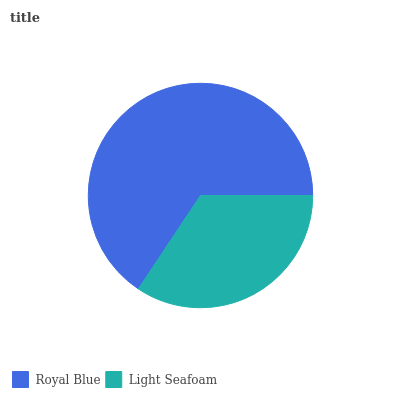Is Light Seafoam the minimum?
Answer yes or no. Yes. Is Royal Blue the maximum?
Answer yes or no. Yes. Is Light Seafoam the maximum?
Answer yes or no. No. Is Royal Blue greater than Light Seafoam?
Answer yes or no. Yes. Is Light Seafoam less than Royal Blue?
Answer yes or no. Yes. Is Light Seafoam greater than Royal Blue?
Answer yes or no. No. Is Royal Blue less than Light Seafoam?
Answer yes or no. No. Is Royal Blue the high median?
Answer yes or no. Yes. Is Light Seafoam the low median?
Answer yes or no. Yes. Is Light Seafoam the high median?
Answer yes or no. No. Is Royal Blue the low median?
Answer yes or no. No. 